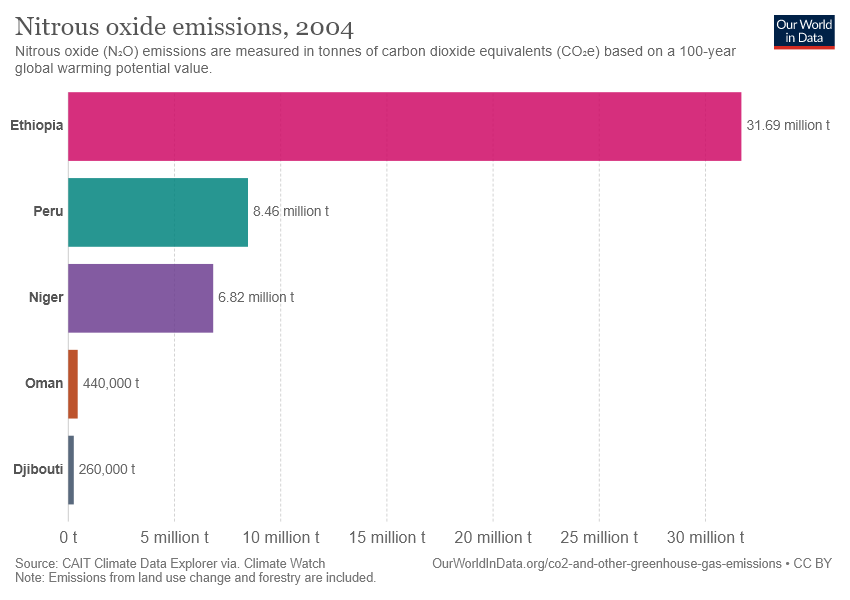Point out several critical features in this image. Peru's data in million tonnes is 8.46. Ethiopia has higher data than Peru, with a value of 23.23. 